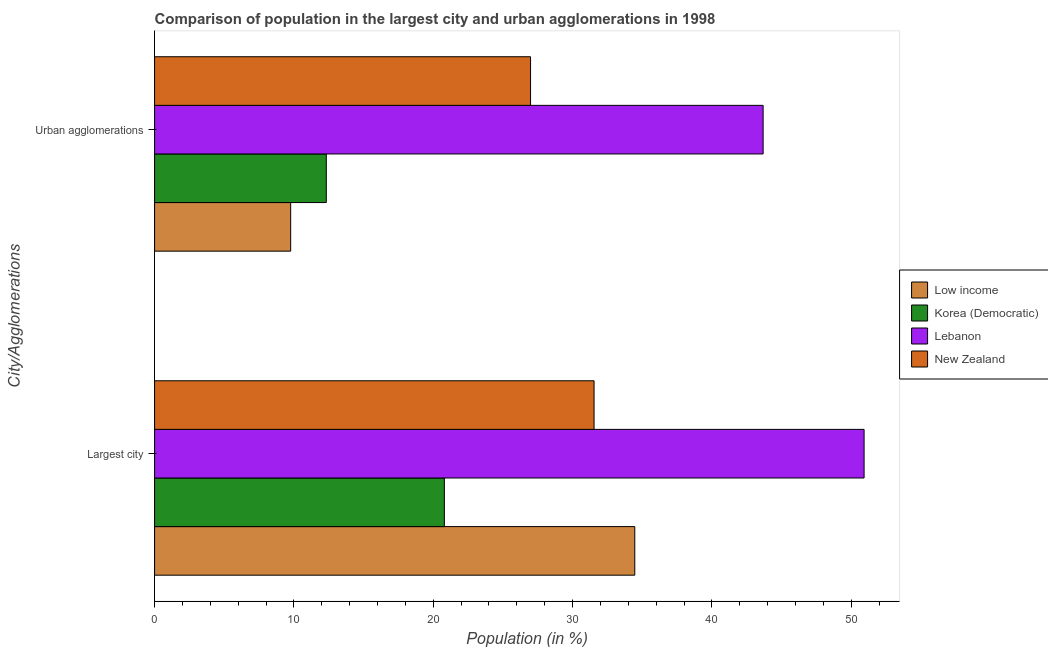How many different coloured bars are there?
Your answer should be compact. 4. Are the number of bars on each tick of the Y-axis equal?
Provide a succinct answer. Yes. How many bars are there on the 2nd tick from the bottom?
Provide a succinct answer. 4. What is the label of the 2nd group of bars from the top?
Your answer should be compact. Largest city. What is the population in urban agglomerations in Lebanon?
Give a very brief answer. 43.67. Across all countries, what is the maximum population in the largest city?
Provide a short and direct response. 50.92. Across all countries, what is the minimum population in urban agglomerations?
Your answer should be very brief. 9.77. In which country was the population in the largest city maximum?
Ensure brevity in your answer.  Lebanon. In which country was the population in the largest city minimum?
Make the answer very short. Korea (Democratic). What is the total population in the largest city in the graph?
Keep it short and to the point. 137.72. What is the difference between the population in the largest city in New Zealand and that in Korea (Democratic)?
Your response must be concise. 10.74. What is the difference between the population in the largest city in Lebanon and the population in urban agglomerations in Low income?
Your response must be concise. 41.15. What is the average population in urban agglomerations per country?
Keep it short and to the point. 23.19. What is the difference between the population in the largest city and population in urban agglomerations in Lebanon?
Offer a terse response. 7.25. In how many countries, is the population in the largest city greater than 28 %?
Offer a terse response. 3. What is the ratio of the population in the largest city in New Zealand to that in Lebanon?
Offer a very short reply. 0.62. What does the 3rd bar from the top in Urban agglomerations represents?
Your answer should be very brief. Korea (Democratic). Are all the bars in the graph horizontal?
Ensure brevity in your answer.  Yes. How many countries are there in the graph?
Provide a short and direct response. 4. Are the values on the major ticks of X-axis written in scientific E-notation?
Keep it short and to the point. No. What is the title of the graph?
Provide a short and direct response. Comparison of population in the largest city and urban agglomerations in 1998. Does "Saudi Arabia" appear as one of the legend labels in the graph?
Your answer should be compact. No. What is the label or title of the X-axis?
Give a very brief answer. Population (in %). What is the label or title of the Y-axis?
Keep it short and to the point. City/Agglomerations. What is the Population (in %) of Low income in Largest city?
Provide a succinct answer. 34.46. What is the Population (in %) in Korea (Democratic) in Largest city?
Ensure brevity in your answer.  20.8. What is the Population (in %) of Lebanon in Largest city?
Offer a terse response. 50.92. What is the Population (in %) in New Zealand in Largest city?
Make the answer very short. 31.54. What is the Population (in %) of Low income in Urban agglomerations?
Ensure brevity in your answer.  9.77. What is the Population (in %) of Korea (Democratic) in Urban agglomerations?
Make the answer very short. 12.32. What is the Population (in %) of Lebanon in Urban agglomerations?
Keep it short and to the point. 43.67. What is the Population (in %) of New Zealand in Urban agglomerations?
Give a very brief answer. 26.98. Across all City/Agglomerations, what is the maximum Population (in %) of Low income?
Your answer should be compact. 34.46. Across all City/Agglomerations, what is the maximum Population (in %) of Korea (Democratic)?
Offer a terse response. 20.8. Across all City/Agglomerations, what is the maximum Population (in %) of Lebanon?
Offer a terse response. 50.92. Across all City/Agglomerations, what is the maximum Population (in %) of New Zealand?
Your answer should be compact. 31.54. Across all City/Agglomerations, what is the minimum Population (in %) in Low income?
Your answer should be compact. 9.77. Across all City/Agglomerations, what is the minimum Population (in %) in Korea (Democratic)?
Make the answer very short. 12.32. Across all City/Agglomerations, what is the minimum Population (in %) in Lebanon?
Keep it short and to the point. 43.67. Across all City/Agglomerations, what is the minimum Population (in %) of New Zealand?
Your answer should be compact. 26.98. What is the total Population (in %) in Low income in the graph?
Ensure brevity in your answer.  44.23. What is the total Population (in %) in Korea (Democratic) in the graph?
Keep it short and to the point. 33.12. What is the total Population (in %) in Lebanon in the graph?
Offer a terse response. 94.59. What is the total Population (in %) of New Zealand in the graph?
Your answer should be compact. 58.52. What is the difference between the Population (in %) of Low income in Largest city and that in Urban agglomerations?
Make the answer very short. 24.7. What is the difference between the Population (in %) in Korea (Democratic) in Largest city and that in Urban agglomerations?
Keep it short and to the point. 8.47. What is the difference between the Population (in %) of Lebanon in Largest city and that in Urban agglomerations?
Give a very brief answer. 7.25. What is the difference between the Population (in %) of New Zealand in Largest city and that in Urban agglomerations?
Your response must be concise. 4.56. What is the difference between the Population (in %) of Low income in Largest city and the Population (in %) of Korea (Democratic) in Urban agglomerations?
Offer a very short reply. 22.14. What is the difference between the Population (in %) of Low income in Largest city and the Population (in %) of Lebanon in Urban agglomerations?
Your answer should be compact. -9.21. What is the difference between the Population (in %) in Low income in Largest city and the Population (in %) in New Zealand in Urban agglomerations?
Provide a short and direct response. 7.48. What is the difference between the Population (in %) of Korea (Democratic) in Largest city and the Population (in %) of Lebanon in Urban agglomerations?
Make the answer very short. -22.88. What is the difference between the Population (in %) of Korea (Democratic) in Largest city and the Population (in %) of New Zealand in Urban agglomerations?
Give a very brief answer. -6.18. What is the difference between the Population (in %) of Lebanon in Largest city and the Population (in %) of New Zealand in Urban agglomerations?
Provide a short and direct response. 23.94. What is the average Population (in %) of Low income per City/Agglomerations?
Your response must be concise. 22.12. What is the average Population (in %) in Korea (Democratic) per City/Agglomerations?
Your response must be concise. 16.56. What is the average Population (in %) of Lebanon per City/Agglomerations?
Provide a short and direct response. 47.3. What is the average Population (in %) in New Zealand per City/Agglomerations?
Keep it short and to the point. 29.26. What is the difference between the Population (in %) of Low income and Population (in %) of Korea (Democratic) in Largest city?
Give a very brief answer. 13.67. What is the difference between the Population (in %) of Low income and Population (in %) of Lebanon in Largest city?
Offer a terse response. -16.46. What is the difference between the Population (in %) in Low income and Population (in %) in New Zealand in Largest city?
Offer a terse response. 2.92. What is the difference between the Population (in %) in Korea (Democratic) and Population (in %) in Lebanon in Largest city?
Offer a very short reply. -30.12. What is the difference between the Population (in %) of Korea (Democratic) and Population (in %) of New Zealand in Largest city?
Give a very brief answer. -10.74. What is the difference between the Population (in %) in Lebanon and Population (in %) in New Zealand in Largest city?
Your answer should be very brief. 19.38. What is the difference between the Population (in %) in Low income and Population (in %) in Korea (Democratic) in Urban agglomerations?
Offer a terse response. -2.56. What is the difference between the Population (in %) in Low income and Population (in %) in Lebanon in Urban agglomerations?
Make the answer very short. -33.91. What is the difference between the Population (in %) in Low income and Population (in %) in New Zealand in Urban agglomerations?
Keep it short and to the point. -17.22. What is the difference between the Population (in %) of Korea (Democratic) and Population (in %) of Lebanon in Urban agglomerations?
Make the answer very short. -31.35. What is the difference between the Population (in %) of Korea (Democratic) and Population (in %) of New Zealand in Urban agglomerations?
Your answer should be compact. -14.66. What is the difference between the Population (in %) in Lebanon and Population (in %) in New Zealand in Urban agglomerations?
Provide a short and direct response. 16.69. What is the ratio of the Population (in %) in Low income in Largest city to that in Urban agglomerations?
Your response must be concise. 3.53. What is the ratio of the Population (in %) in Korea (Democratic) in Largest city to that in Urban agglomerations?
Offer a terse response. 1.69. What is the ratio of the Population (in %) in Lebanon in Largest city to that in Urban agglomerations?
Ensure brevity in your answer.  1.17. What is the ratio of the Population (in %) in New Zealand in Largest city to that in Urban agglomerations?
Keep it short and to the point. 1.17. What is the difference between the highest and the second highest Population (in %) of Low income?
Provide a succinct answer. 24.7. What is the difference between the highest and the second highest Population (in %) of Korea (Democratic)?
Keep it short and to the point. 8.47. What is the difference between the highest and the second highest Population (in %) in Lebanon?
Make the answer very short. 7.25. What is the difference between the highest and the second highest Population (in %) in New Zealand?
Ensure brevity in your answer.  4.56. What is the difference between the highest and the lowest Population (in %) in Low income?
Your response must be concise. 24.7. What is the difference between the highest and the lowest Population (in %) in Korea (Democratic)?
Offer a terse response. 8.47. What is the difference between the highest and the lowest Population (in %) of Lebanon?
Offer a very short reply. 7.25. What is the difference between the highest and the lowest Population (in %) of New Zealand?
Make the answer very short. 4.56. 